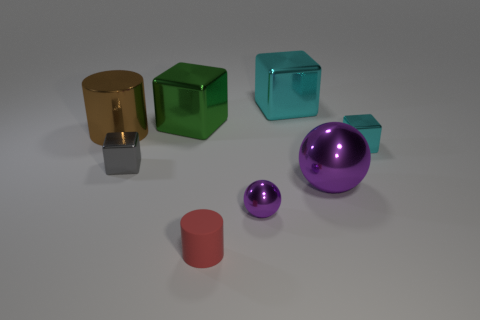There is another object that is the same shape as the tiny rubber object; what size is it?
Ensure brevity in your answer.  Large. There is a large cyan metallic thing right of the gray block that is to the left of the tiny red object; how many small purple shiny objects are behind it?
Provide a succinct answer. 0. Are there the same number of small red rubber objects right of the small red matte object and large metal things?
Ensure brevity in your answer.  No. What number of blocks are either small cyan things or large cyan objects?
Your answer should be compact. 2. Does the matte cylinder have the same color as the large ball?
Offer a terse response. No. Are there an equal number of purple metallic balls that are left of the tiny gray metal block and brown metallic cylinders to the right of the green block?
Your response must be concise. Yes. What is the color of the small matte cylinder?
Ensure brevity in your answer.  Red. What number of things are either large metal blocks to the right of the red object or shiny objects?
Provide a succinct answer. 7. Does the cylinder that is behind the red thing have the same size as the purple sphere to the right of the small sphere?
Your answer should be very brief. Yes. Are there any other things that have the same material as the large purple thing?
Your response must be concise. Yes. 